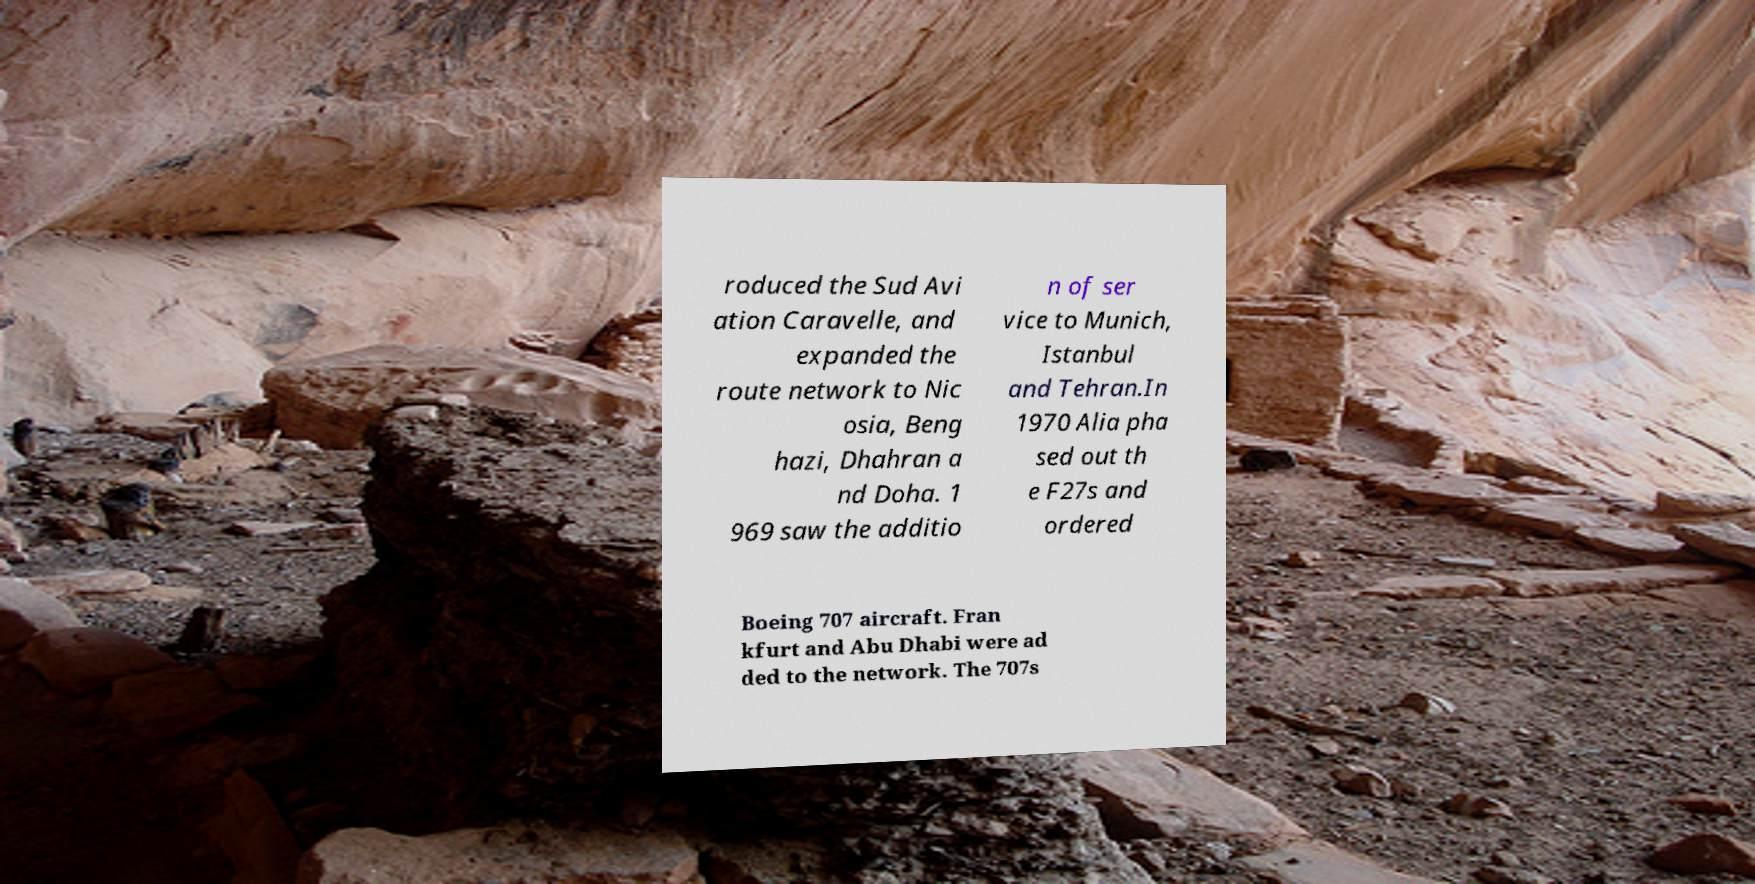Can you read and provide the text displayed in the image?This photo seems to have some interesting text. Can you extract and type it out for me? roduced the Sud Avi ation Caravelle, and expanded the route network to Nic osia, Beng hazi, Dhahran a nd Doha. 1 969 saw the additio n of ser vice to Munich, Istanbul and Tehran.In 1970 Alia pha sed out th e F27s and ordered Boeing 707 aircraft. Fran kfurt and Abu Dhabi were ad ded to the network. The 707s 